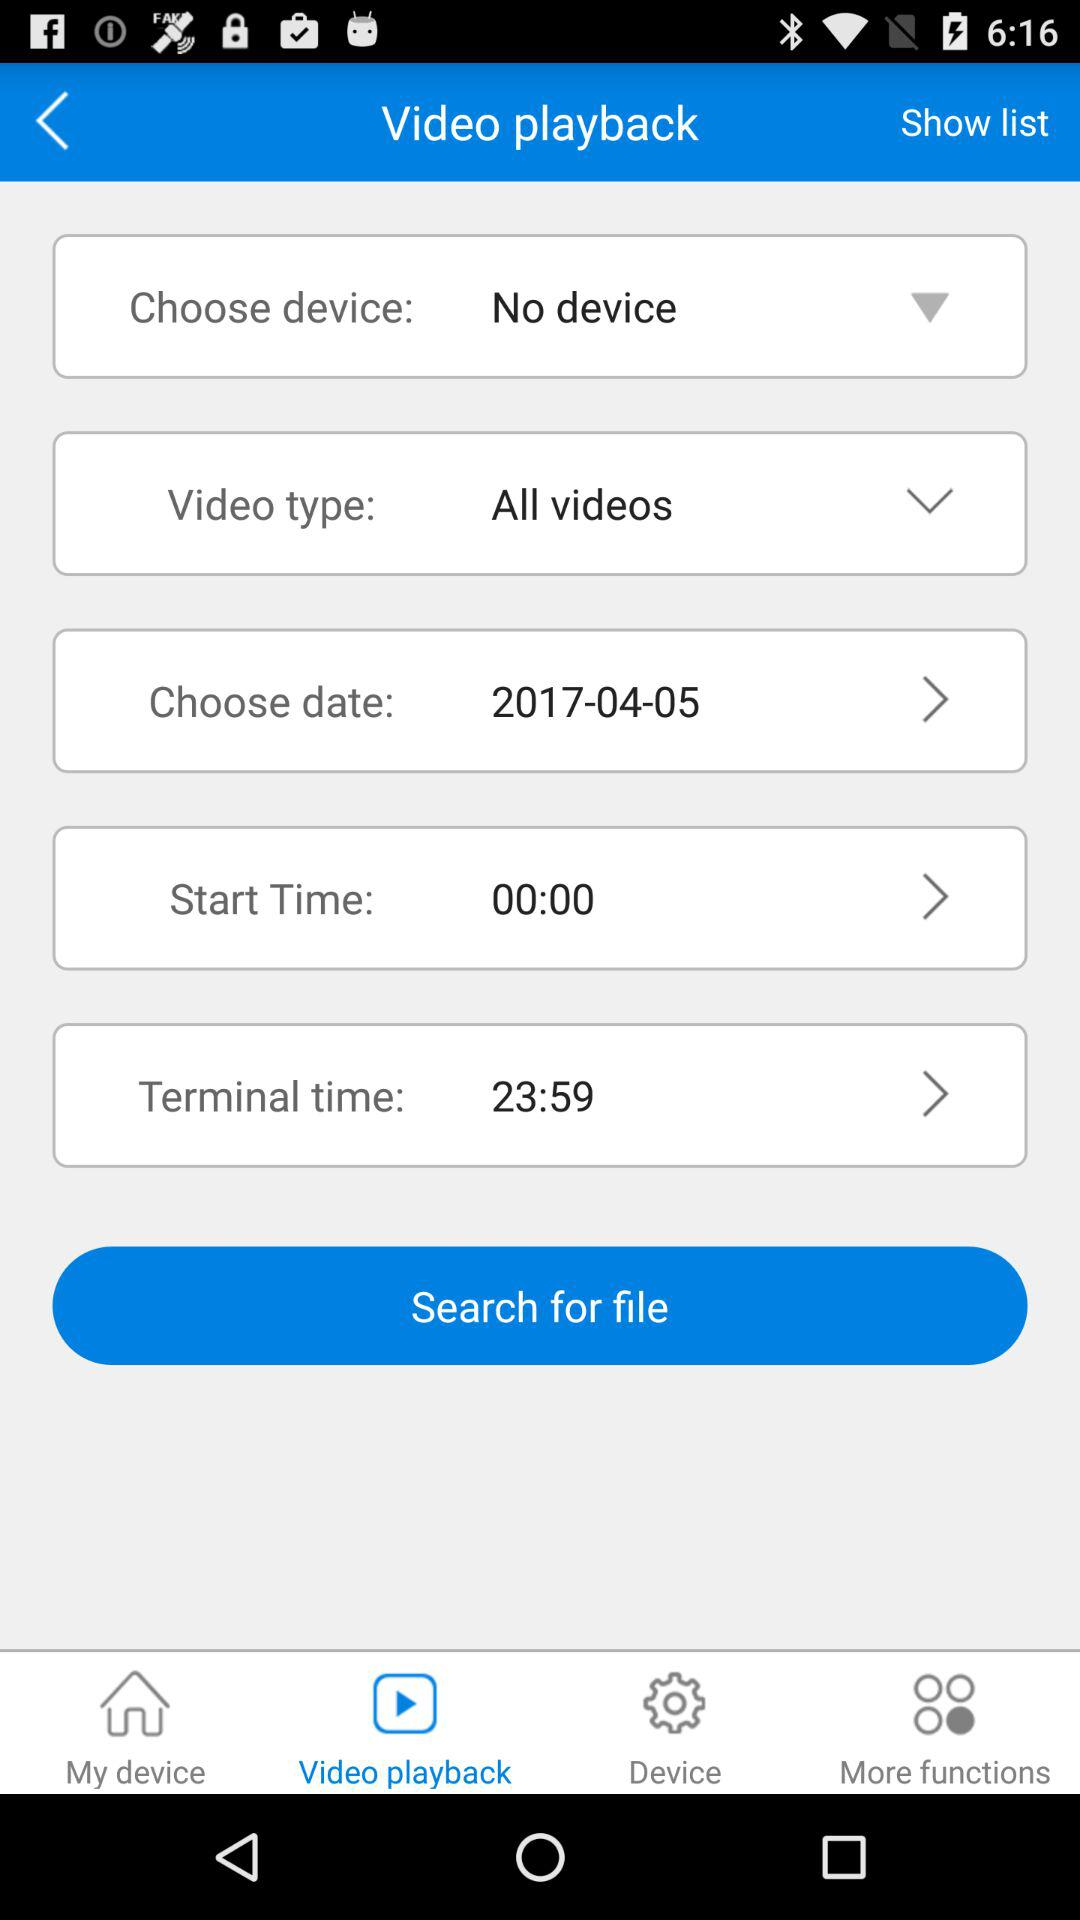What is the terminal time? The terminal time is 23:59. 